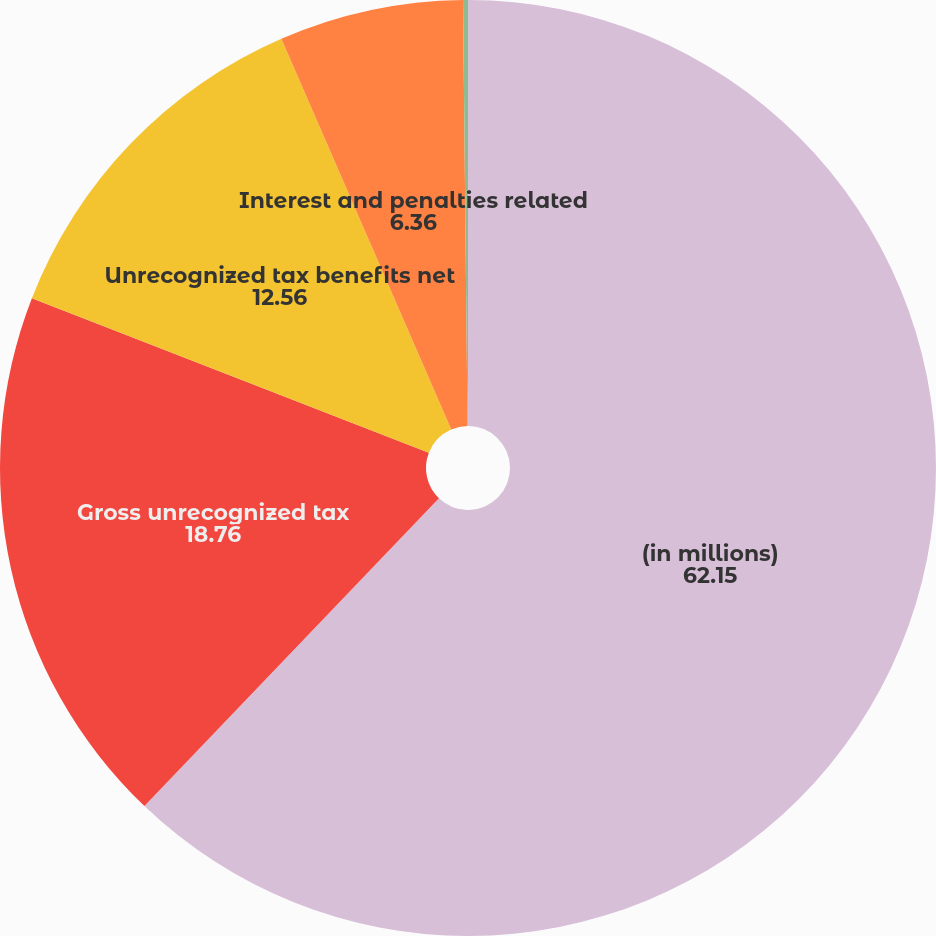Convert chart to OTSL. <chart><loc_0><loc_0><loc_500><loc_500><pie_chart><fcel>(in millions)<fcel>Gross unrecognized tax<fcel>Unrecognized tax benefits net<fcel>Interest and penalties related<fcel>Interest and penalties<nl><fcel>62.15%<fcel>18.76%<fcel>12.56%<fcel>6.36%<fcel>0.17%<nl></chart> 